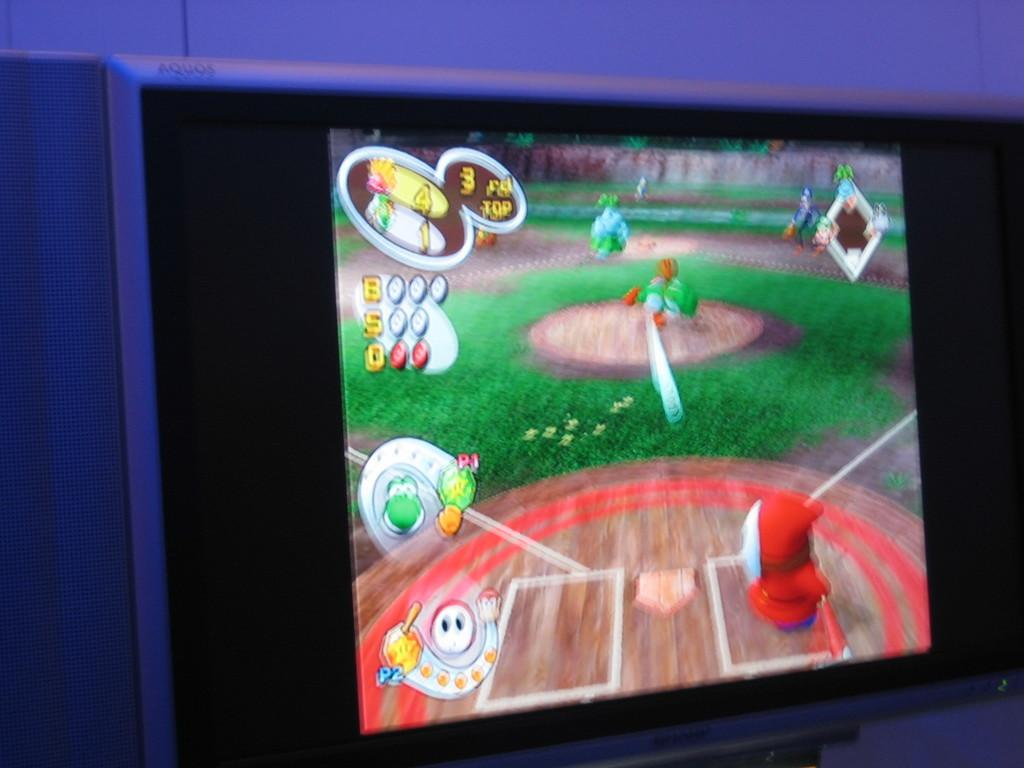<image>
Present a compact description of the photo's key features. A screen showing a video game that includes Yoshi playing a sport. 